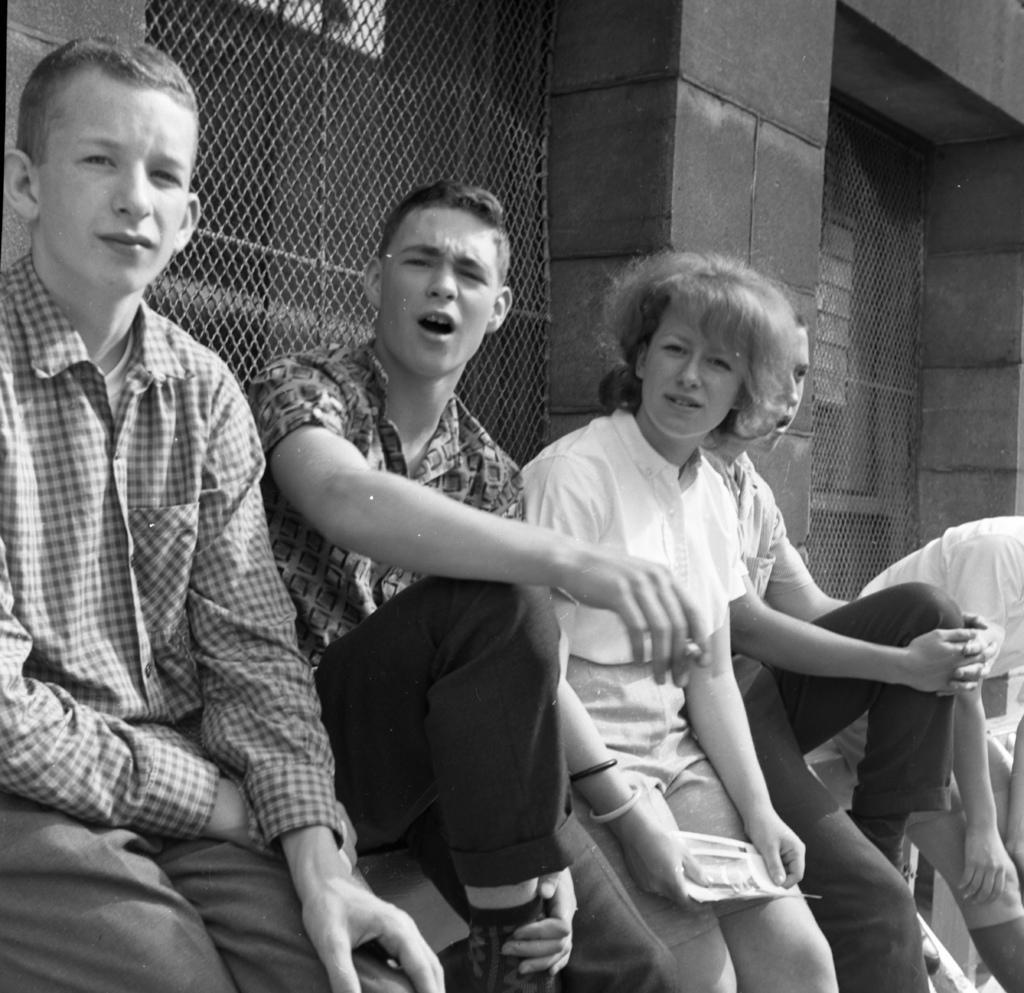How would you summarize this image in a sentence or two? This is a black and white image. In this image we can see a group of people sitting beside a metal grill. In that a woman is holding some papers. On the backside we can see a wall. 